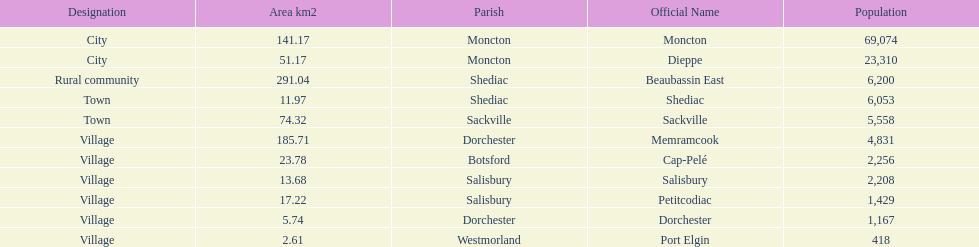Which city has the largest population? Moncton. 